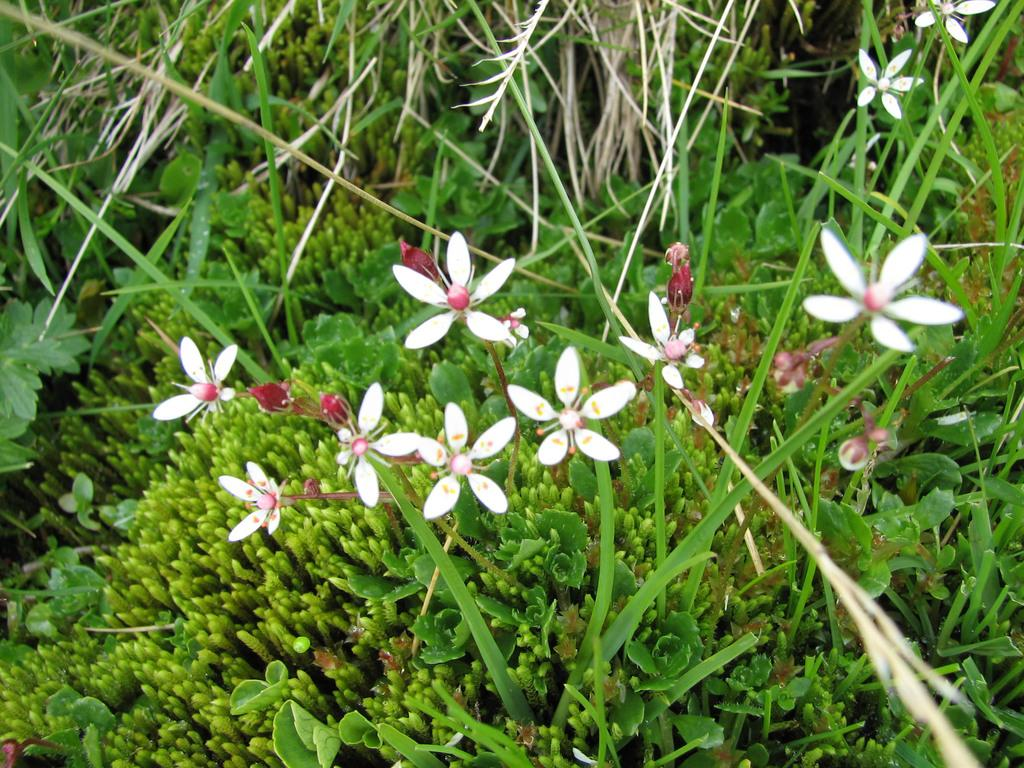What is the main subject in the center of the image? There are flowers in the center of the image. What can be seen in the background of the image? There are leaves and plants in the background of the image. What type of farm animals can be seen in the image? There are no farm animals present in the image; it features flowers and plants. How many yards of land are visible in the image? There is no yard visible in the image, as it focuses on flowers and plants. 